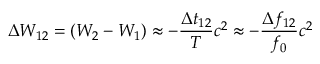<formula> <loc_0><loc_0><loc_500><loc_500>\Delta W _ { 1 2 } = \left ( W _ { 2 } - W _ { 1 } \right ) \approx - \frac { \Delta t _ { 1 2 } } { T } c ^ { 2 } \approx - \frac { \Delta f _ { 1 2 } } { f _ { 0 } } c ^ { 2 }</formula> 